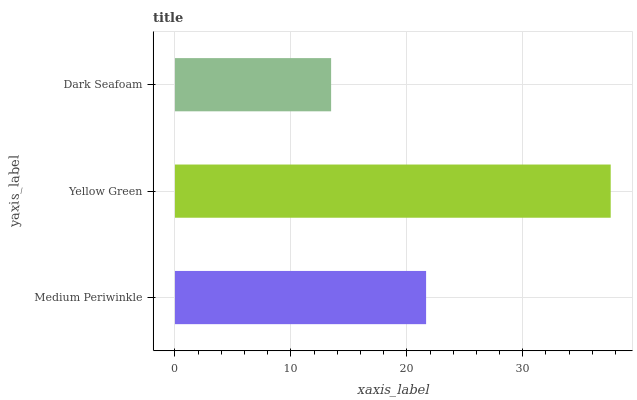Is Dark Seafoam the minimum?
Answer yes or no. Yes. Is Yellow Green the maximum?
Answer yes or no. Yes. Is Yellow Green the minimum?
Answer yes or no. No. Is Dark Seafoam the maximum?
Answer yes or no. No. Is Yellow Green greater than Dark Seafoam?
Answer yes or no. Yes. Is Dark Seafoam less than Yellow Green?
Answer yes or no. Yes. Is Dark Seafoam greater than Yellow Green?
Answer yes or no. No. Is Yellow Green less than Dark Seafoam?
Answer yes or no. No. Is Medium Periwinkle the high median?
Answer yes or no. Yes. Is Medium Periwinkle the low median?
Answer yes or no. Yes. Is Dark Seafoam the high median?
Answer yes or no. No. Is Yellow Green the low median?
Answer yes or no. No. 